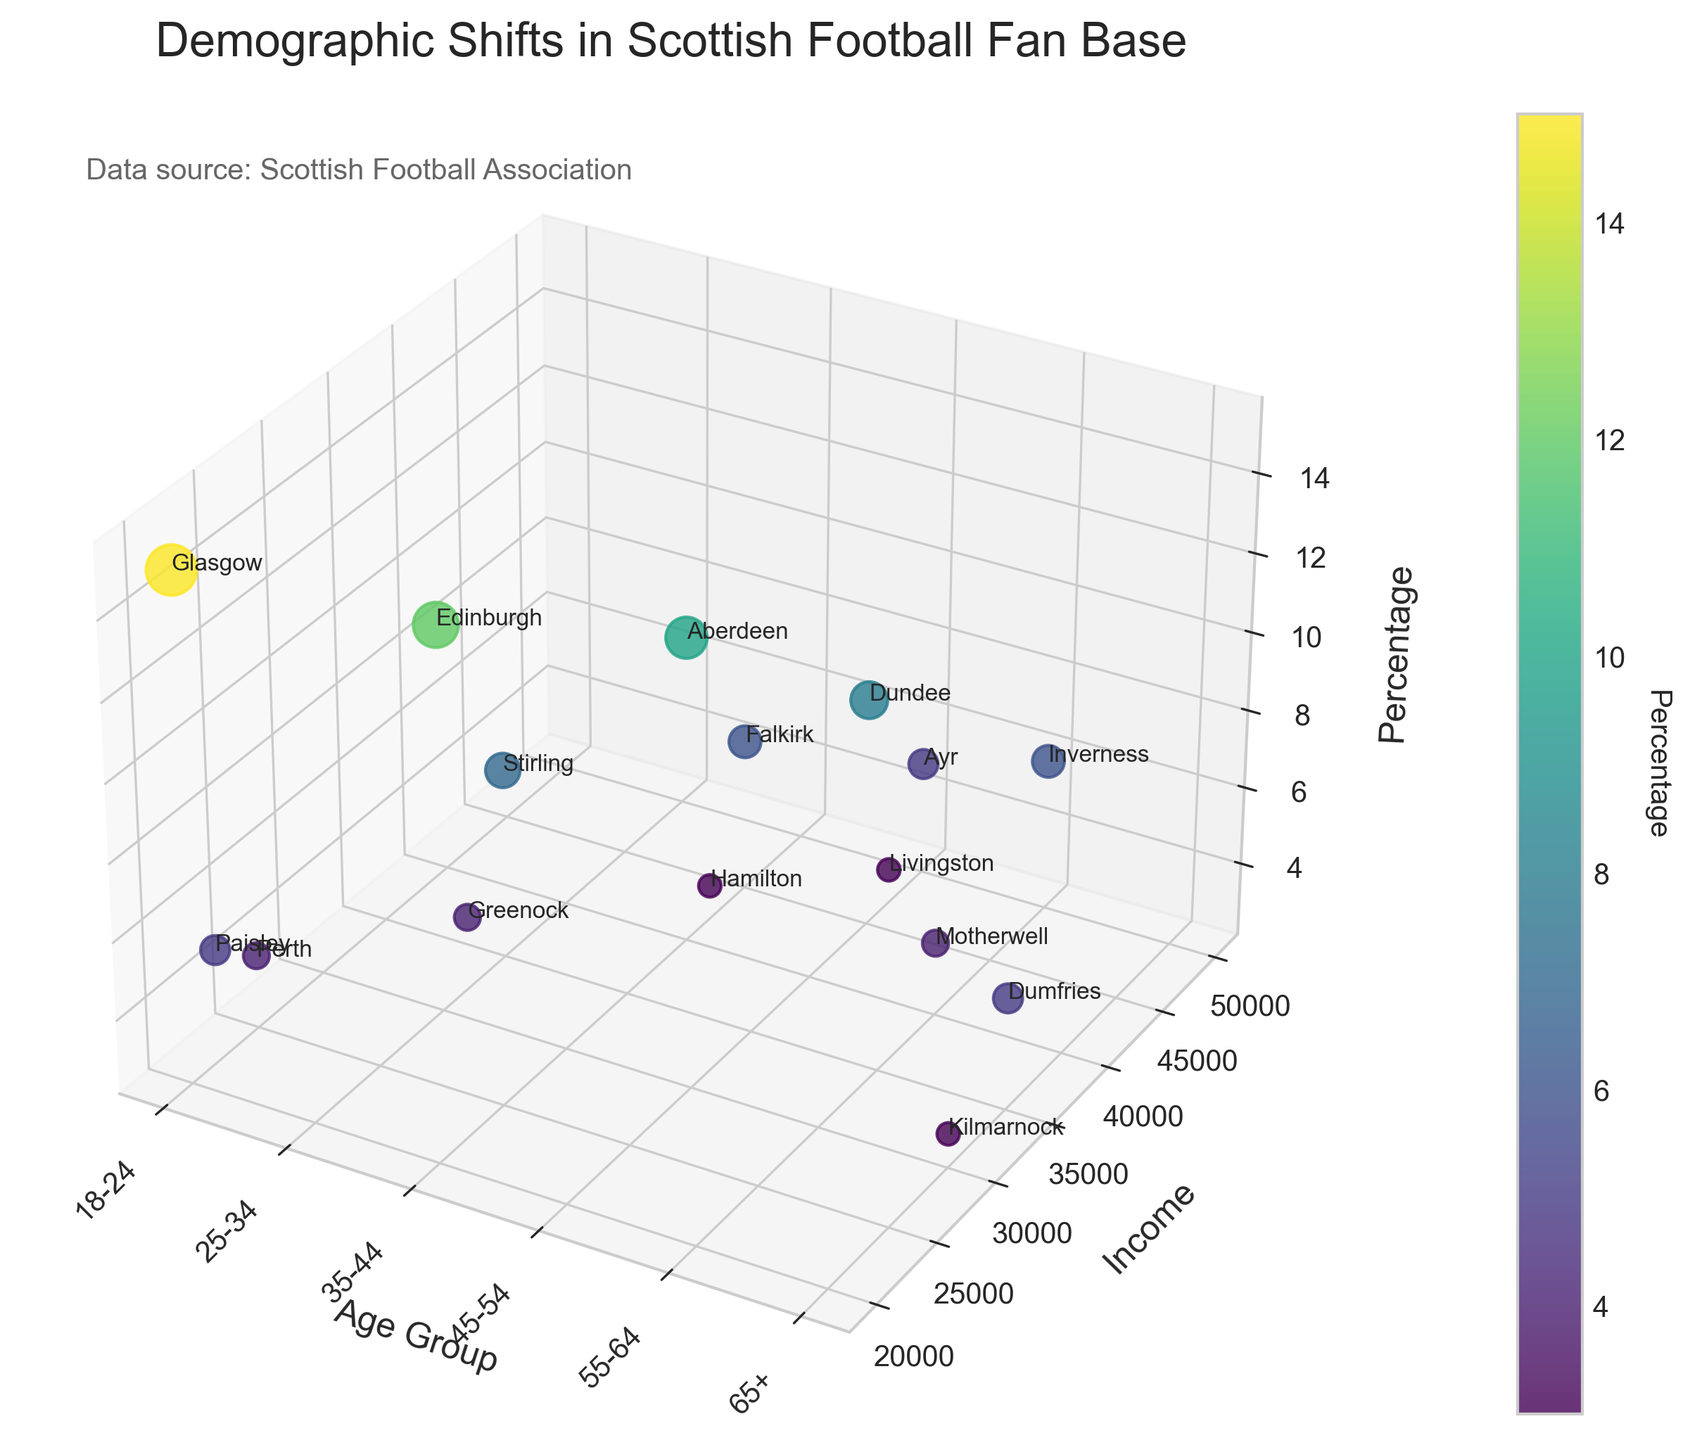What is the title of the figure? The title of the figure is displayed at the top and is typically larger and bolder than any other text on the figure.
Answer: Demographic Shifts in Scottish Football Fan Base Which age group has the highest representation in terms of percentage? Look at the z-axis labeled 'Percentage' and identify the age group with the highest value along this axis. The scatter point for '18-24' age group in Glasgow is at the highest point on the z-axis.
Answer: 18-24 What are the labels on the x-axis? The x-axis is labeled with different age groups. The ticks correspond to these age groups, which are written along the axis at an angle for better readability.
Answer: 18-24, 25-34, 35-44, 45-54, 55-64, 65+ How many data points are there in total on the figure? Count all the scatter points visible in the 3D plot. There are data points for different age groups, each with a percentage and income value.
Answer: 16 Which region represents the 55-64 age group with the smallest percentage, and what is that percentage? Find 55-64 age groups on the x-axis and identify the scatter point with the lowest percentage on the z-axis. In the 55-64 age group, the scatter point for Motherwell has the lowest percentage.
Answer: Motherwell, 4 What is the average income for the 25-34 age group? Add up the incomes for all scatter points corresponding to the 25-34 age group on the x-axis and divide by the number of data points in that group. Incomes are: 30000 (Edinburgh), 35000 (Stirling), and 32000 (Greenock), so the average is (30000 + 35000 + 32000) / 3 = 32333.33
Answer: 32333.33 Which two age groups have the closest average incomes? Calculate the average income for each age group and compare to find which two are closest. 
- 18-24: (20000 (Glasgow) + 25000 (Perth) + 22000 (Paisley)) / 3 = 22333.33 
- 25-34: (30000 (Edinburgh) + 35000 (Stirling) + 32000 (Greenock)) / 3 = 32333.33 
- 35-44: (40000 (Aberdeen) + 45000 (Falkirk) + 42000 (Hamilton)) / 3 = 42333.33 
- 45-54: (45000 (Dundee) + 50000 (Ayr) + 47000 (Livingston)) / 3 = 47333.33 
- 55-64: (50000 (Inverness) + 40000 (Motherwell)) / 2 = 45000
- 65+: (35000 (Dumfries) + 30000 (Kilmarnock)) / 2 = 32500. Therefore, 25-34 and 65+ have averages of 32333.33 and 32500 respectively, which are the closest.
Answer: 25-34, 65+ Is there any region that has data points in more than one age group? Observe the labels near the scatter points to check if any region name repeats across different age groups. Each scatter point has a region label but none of them repeat.
Answer: No Which region in the 45-54 age group has the highest income? Look at the scatter points along the x-axis labeled '45-54' and compare the income values on the y-axis. The region with the highest point on the y-axis in this group is Livingston.
Answer: Livingston 